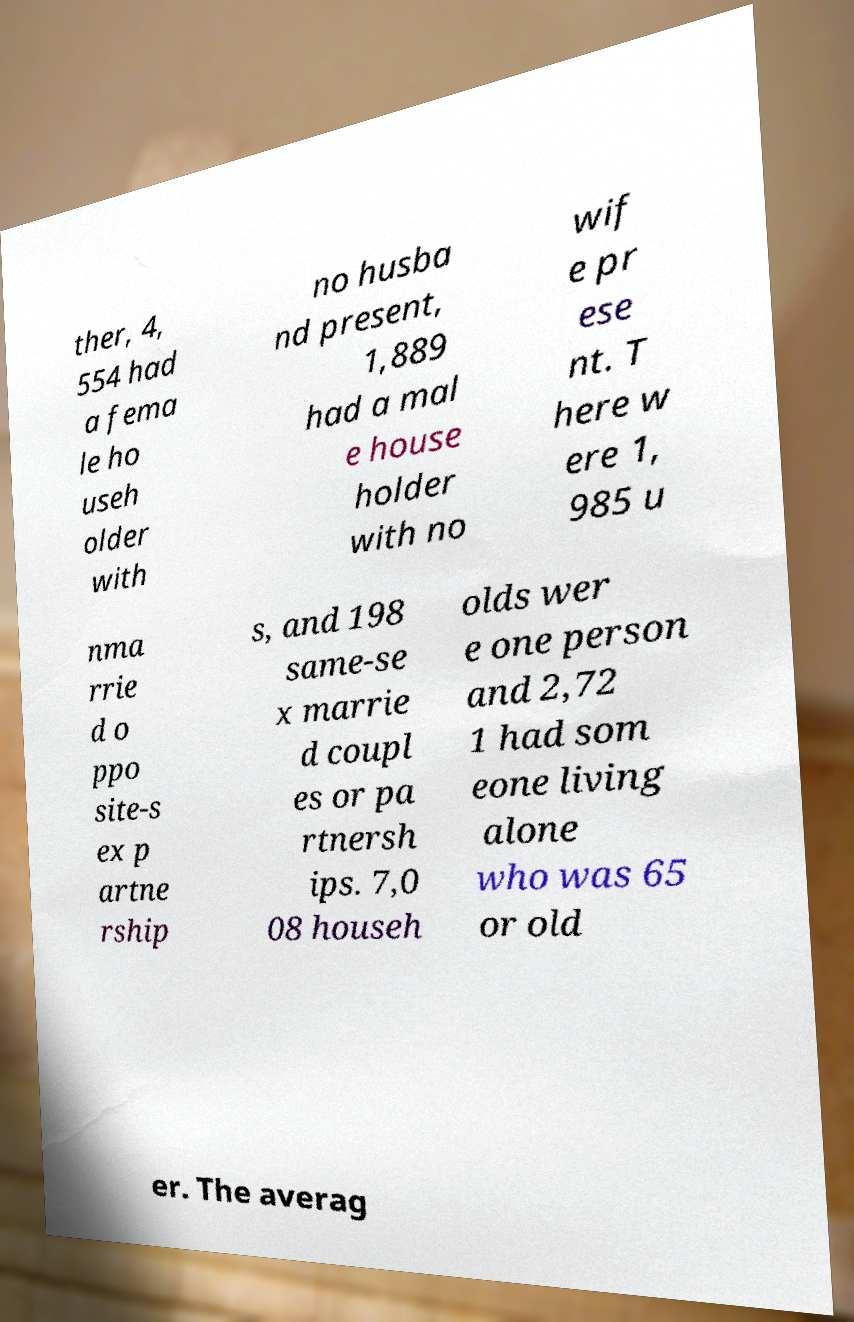Can you accurately transcribe the text from the provided image for me? ther, 4, 554 had a fema le ho useh older with no husba nd present, 1,889 had a mal e house holder with no wif e pr ese nt. T here w ere 1, 985 u nma rrie d o ppo site-s ex p artne rship s, and 198 same-se x marrie d coupl es or pa rtnersh ips. 7,0 08 househ olds wer e one person and 2,72 1 had som eone living alone who was 65 or old er. The averag 